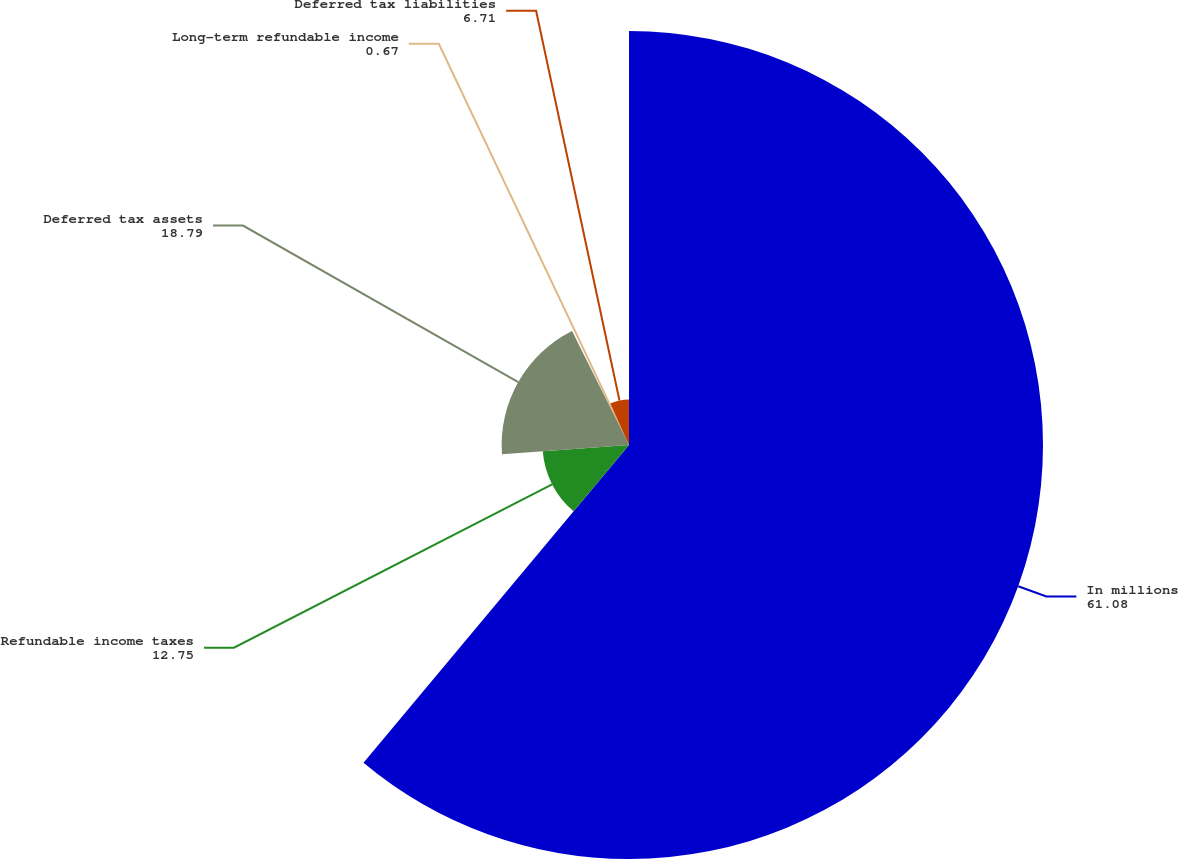Convert chart. <chart><loc_0><loc_0><loc_500><loc_500><pie_chart><fcel>In millions<fcel>Refundable income taxes<fcel>Deferred tax assets<fcel>Long-term refundable income<fcel>Deferred tax liabilities<nl><fcel>61.08%<fcel>12.75%<fcel>18.79%<fcel>0.67%<fcel>6.71%<nl></chart> 